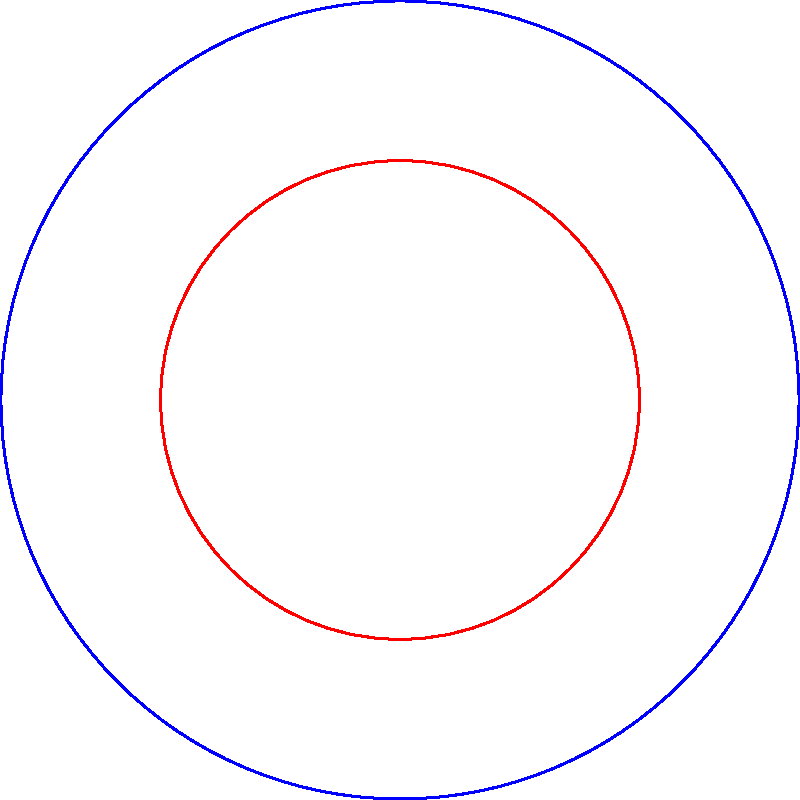In a strategic military briefing, you're presented with a diagram showing the range and coverage area of two types of missiles. The long-range missile has a maximum range of 500 km and covers a 90-degree sector. The short-range missile has a maximum range of 300 km and covers a 90-degree sector. What is the ratio of the coverage area of the long-range missile to the short-range missile? To solve this problem, we need to follow these steps:

1) The area of a sector is given by the formula: $A = \frac{1}{2}r^2\theta$, where $r$ is the radius and $\theta$ is the angle in radians.

2) For both missiles, the angle is 90 degrees, which is $\frac{\pi}{2}$ radians.

3) For the long-range missile:
   $A_1 = \frac{1}{2}(500)^2 \cdot \frac{\pi}{2} = 62,500\pi$ km²

4) For the short-range missile:
   $A_2 = \frac{1}{2}(300)^2 \cdot \frac{\pi}{2} = 22,500\pi$ km²

5) The ratio of the coverage areas is:
   $\frac{A_1}{A_2} = \frac{62,500\pi}{22,500\pi} = \frac{62,500}{22,500} = \frac{25}{9}$

Therefore, the coverage area of the long-range missile is $\frac{25}{9}$ times larger than that of the short-range missile.
Answer: $\frac{25}{9}$ 